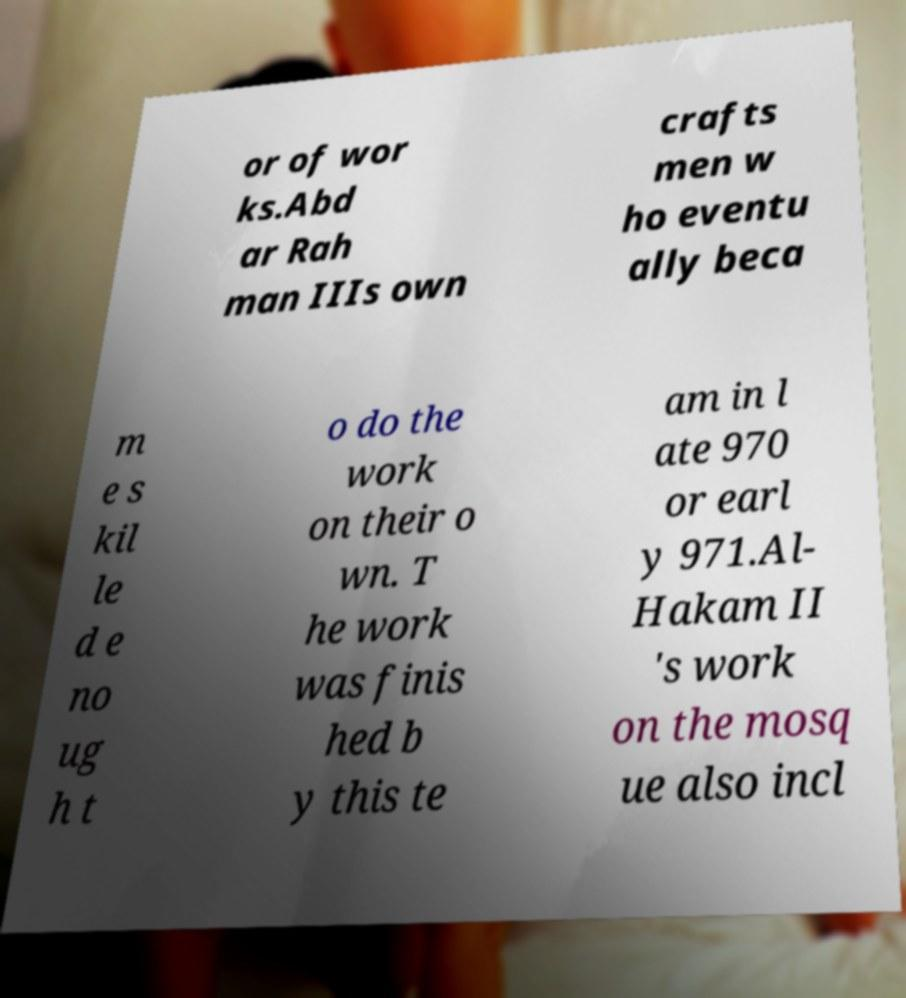There's text embedded in this image that I need extracted. Can you transcribe it verbatim? or of wor ks.Abd ar Rah man IIIs own crafts men w ho eventu ally beca m e s kil le d e no ug h t o do the work on their o wn. T he work was finis hed b y this te am in l ate 970 or earl y 971.Al- Hakam II 's work on the mosq ue also incl 